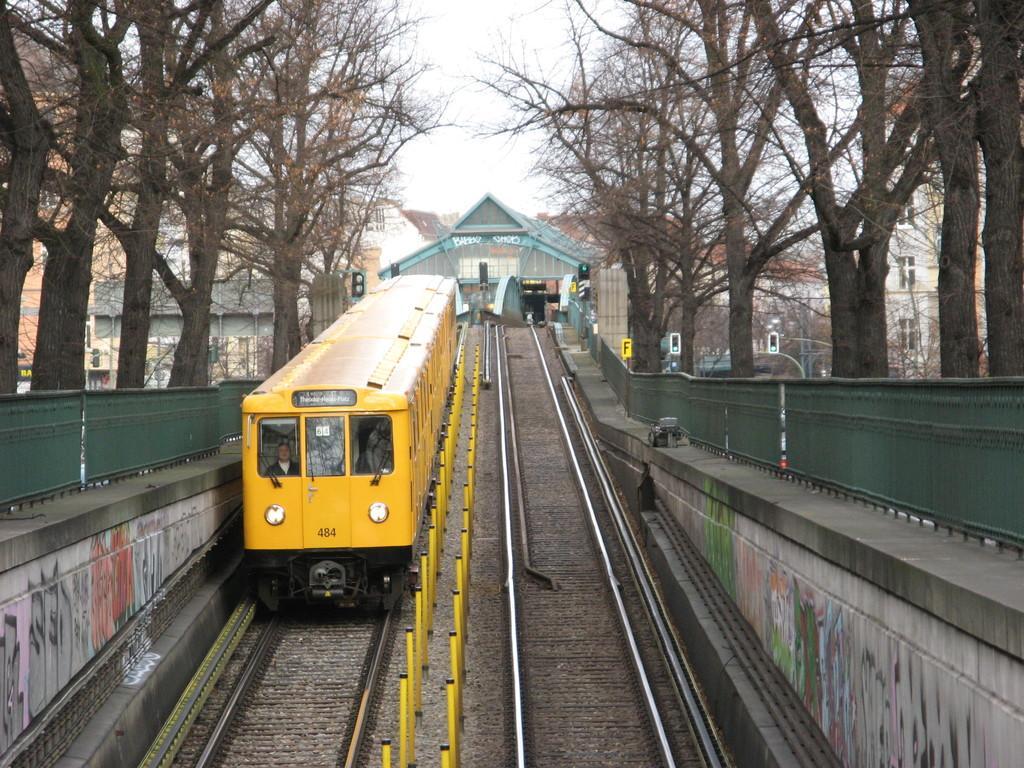In one or two sentences, can you explain what this image depicts? In the image there is a yellow train going on the track with a fence on either side of it followed by trees behind it and in the background there are buildings and above its sky. 